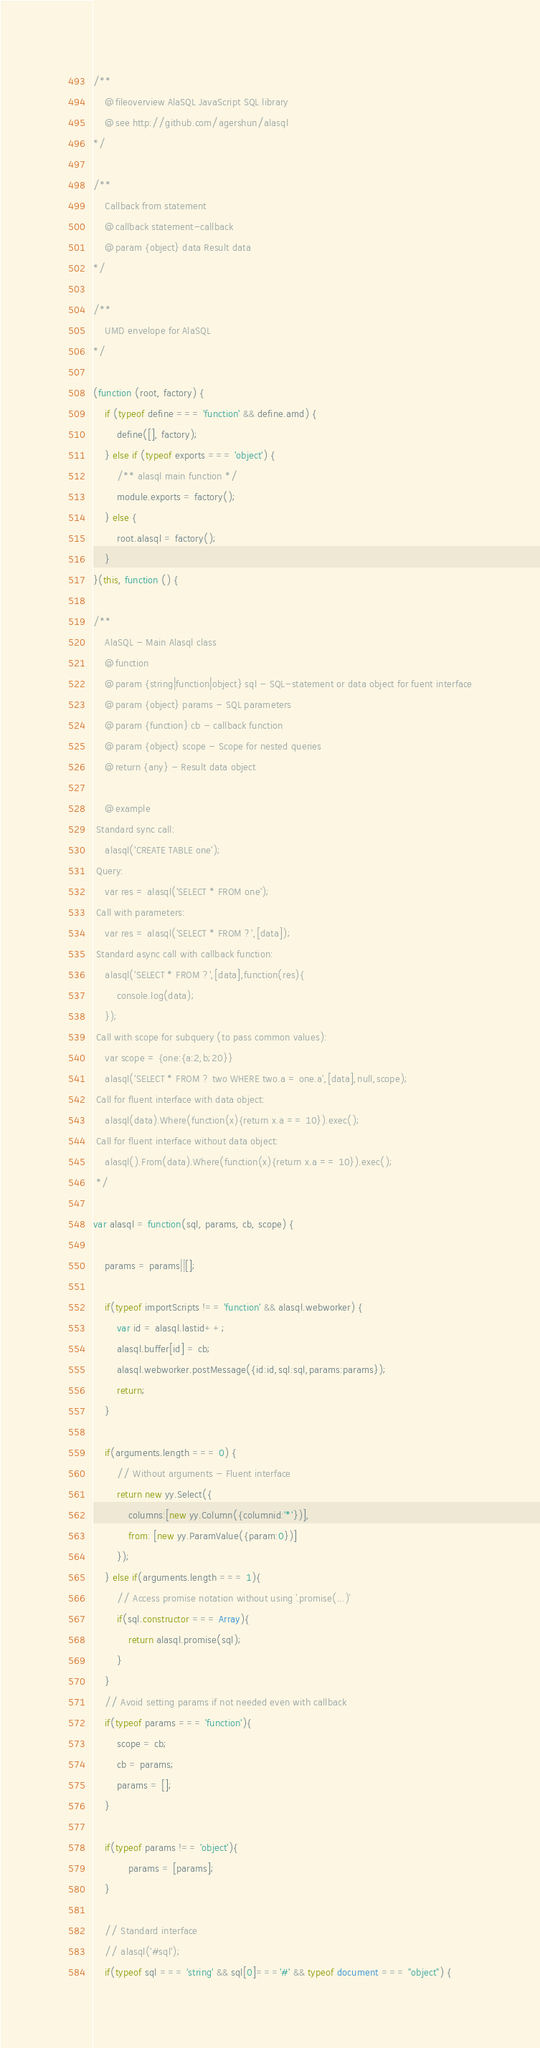Convert code to text. <code><loc_0><loc_0><loc_500><loc_500><_JavaScript_>/**
	@fileoverview AlaSQL JavaScript SQL library
	@see http://github.com/agershun/alasql
*/

/**
	Callback from statement
	@callback statement-callback
	@param {object} data Result data
*/

/**
	UMD envelope for AlaSQL
*/

(function (root, factory) {
    if (typeof define === 'function' && define.amd) {
        define([], factory);
    } else if (typeof exports === 'object') {
    	/** alasql main function */
        module.exports = factory();
    } else {
        root.alasql = factory();
    }
}(this, function () {

/**
	AlaSQL - Main Alasql class
 	@function
 	@param {string|function|object} sql - SQL-statement or data object for fuent interface
 	@param {object} params - SQL parameters
 	@param {function} cb - callback function
 	@param {object} scope - Scope for nested queries
 	@return {any} - Result data object

	@example
 Standard sync call:
    alasql('CREATE TABLE one');
 Query:
 	var res = alasql('SELECT * FROM one');
 Call with parameters:
 	var res = alasql('SELECT * FROM ?',[data]);
 Standard async call with callback function:
 	alasql('SELECT * FROM ?',[data],function(res){
		console.log(data);
 	});
 Call with scope for subquery (to pass common values):
    var scope = {one:{a:2,b;20}}
    alasql('SELECT * FROM ? two WHERE two.a = one.a',[data],null,scope);
 Call for fluent interface with data object:
    alasql(data).Where(function(x){return x.a == 10}).exec();
 Call for fluent interface without data object:
    alasql().From(data).Where(function(x){return x.a == 10}).exec();
 */

var alasql = function(sql, params, cb, scope) {
	
	params = params||[];

	if(typeof importScripts !== 'function' && alasql.webworker) {
		var id = alasql.lastid++;
		alasql.buffer[id] = cb;
		alasql.webworker.postMessage({id:id,sql:sql,params:params});
		return;
	} 

	if(arguments.length === 0) {
		// Without arguments - Fluent interface
		return new yy.Select({
			columns:[new yy.Column({columnid:'*'})],
			from: [new yy.ParamValue({param:0})]
		});
	} else if(arguments.length === 1){ 
		// Access promise notation without using `.promise(...)`
		if(sql.constructor === Array){
			return alasql.promise(sql);
		}
	} 
	// Avoid setting params if not needed even with callback
	if(typeof params === 'function'){
		scope = cb;
		cb = params;
		params = [];
	}

	if(typeof params !== 'object'){
			params = [params];
	}

	// Standard interface
	// alasql('#sql');
	if(typeof sql === 'string' && sql[0]==='#' && typeof document === "object") {</code> 